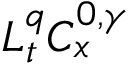<formula> <loc_0><loc_0><loc_500><loc_500>L _ { t } ^ { q } C _ { x } ^ { 0 , \gamma }</formula> 